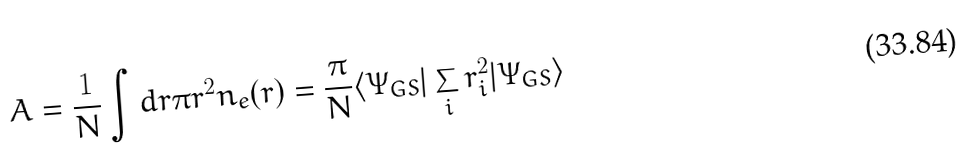<formula> <loc_0><loc_0><loc_500><loc_500>A = \frac { 1 } { N } \int d { r } \pi r ^ { 2 } n _ { e } ( r ) = \frac { \pi } { N } \langle \Psi _ { G S } | \sum _ { i } r _ { i } ^ { 2 } | \Psi _ { G S } \rangle</formula> 